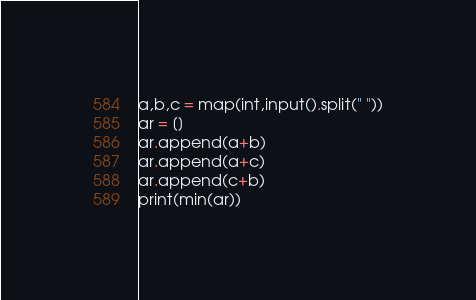Convert code to text. <code><loc_0><loc_0><loc_500><loc_500><_Python_>a,b,c = map(int,input().split(" "))
ar = []
ar.append(a+b)
ar.append(a+c)
ar.append(c+b)
print(min(ar))</code> 